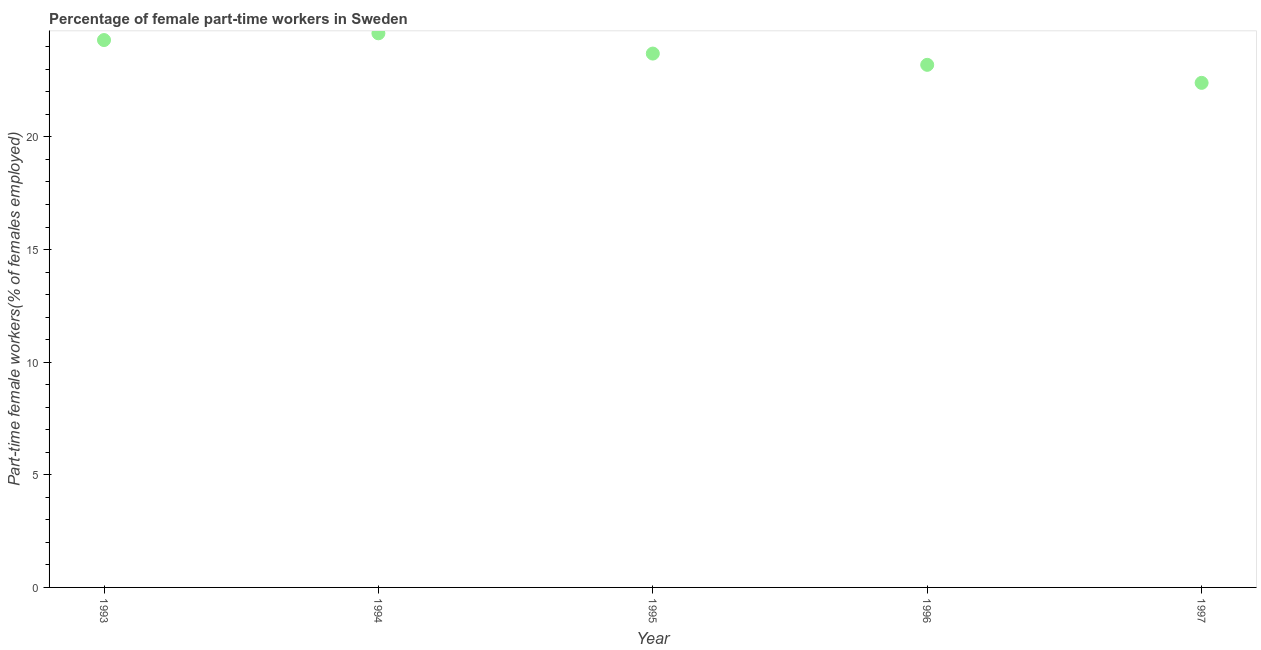What is the percentage of part-time female workers in 1996?
Ensure brevity in your answer.  23.2. Across all years, what is the maximum percentage of part-time female workers?
Give a very brief answer. 24.6. Across all years, what is the minimum percentage of part-time female workers?
Make the answer very short. 22.4. In which year was the percentage of part-time female workers maximum?
Your answer should be compact. 1994. In which year was the percentage of part-time female workers minimum?
Ensure brevity in your answer.  1997. What is the sum of the percentage of part-time female workers?
Keep it short and to the point. 118.2. What is the difference between the percentage of part-time female workers in 1994 and 1996?
Offer a very short reply. 1.4. What is the average percentage of part-time female workers per year?
Offer a terse response. 23.64. What is the median percentage of part-time female workers?
Your response must be concise. 23.7. What is the ratio of the percentage of part-time female workers in 1994 to that in 1997?
Make the answer very short. 1.1. Is the percentage of part-time female workers in 1994 less than that in 1996?
Give a very brief answer. No. Is the difference between the percentage of part-time female workers in 1994 and 1996 greater than the difference between any two years?
Keep it short and to the point. No. What is the difference between the highest and the second highest percentage of part-time female workers?
Your answer should be compact. 0.3. What is the difference between the highest and the lowest percentage of part-time female workers?
Provide a short and direct response. 2.2. In how many years, is the percentage of part-time female workers greater than the average percentage of part-time female workers taken over all years?
Offer a very short reply. 3. How many dotlines are there?
Provide a short and direct response. 1. How many years are there in the graph?
Make the answer very short. 5. What is the difference between two consecutive major ticks on the Y-axis?
Offer a terse response. 5. Are the values on the major ticks of Y-axis written in scientific E-notation?
Provide a short and direct response. No. Does the graph contain grids?
Offer a very short reply. No. What is the title of the graph?
Give a very brief answer. Percentage of female part-time workers in Sweden. What is the label or title of the X-axis?
Make the answer very short. Year. What is the label or title of the Y-axis?
Give a very brief answer. Part-time female workers(% of females employed). What is the Part-time female workers(% of females employed) in 1993?
Keep it short and to the point. 24.3. What is the Part-time female workers(% of females employed) in 1994?
Provide a succinct answer. 24.6. What is the Part-time female workers(% of females employed) in 1995?
Your answer should be very brief. 23.7. What is the Part-time female workers(% of females employed) in 1996?
Provide a short and direct response. 23.2. What is the Part-time female workers(% of females employed) in 1997?
Provide a succinct answer. 22.4. What is the difference between the Part-time female workers(% of females employed) in 1993 and 1994?
Keep it short and to the point. -0.3. What is the difference between the Part-time female workers(% of females employed) in 1993 and 1995?
Keep it short and to the point. 0.6. What is the difference between the Part-time female workers(% of females employed) in 1995 and 1996?
Your answer should be compact. 0.5. What is the difference between the Part-time female workers(% of females employed) in 1995 and 1997?
Your response must be concise. 1.3. What is the ratio of the Part-time female workers(% of females employed) in 1993 to that in 1996?
Your response must be concise. 1.05. What is the ratio of the Part-time female workers(% of females employed) in 1993 to that in 1997?
Make the answer very short. 1.08. What is the ratio of the Part-time female workers(% of females employed) in 1994 to that in 1995?
Ensure brevity in your answer.  1.04. What is the ratio of the Part-time female workers(% of females employed) in 1994 to that in 1996?
Offer a terse response. 1.06. What is the ratio of the Part-time female workers(% of females employed) in 1994 to that in 1997?
Offer a terse response. 1.1. What is the ratio of the Part-time female workers(% of females employed) in 1995 to that in 1996?
Offer a terse response. 1.02. What is the ratio of the Part-time female workers(% of females employed) in 1995 to that in 1997?
Your answer should be compact. 1.06. What is the ratio of the Part-time female workers(% of females employed) in 1996 to that in 1997?
Offer a terse response. 1.04. 